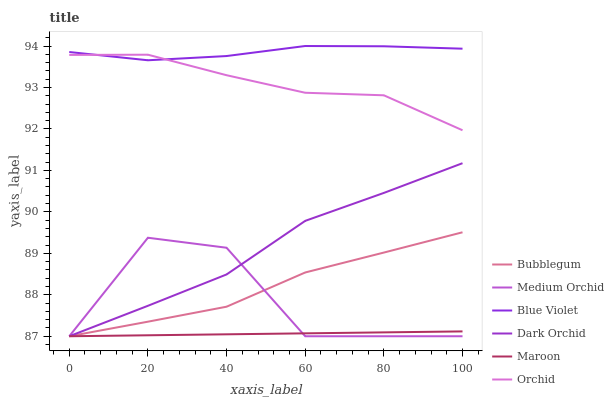Does Maroon have the minimum area under the curve?
Answer yes or no. Yes. Does Blue Violet have the maximum area under the curve?
Answer yes or no. Yes. Does Medium Orchid have the minimum area under the curve?
Answer yes or no. No. Does Medium Orchid have the maximum area under the curve?
Answer yes or no. No. Is Maroon the smoothest?
Answer yes or no. Yes. Is Medium Orchid the roughest?
Answer yes or no. Yes. Is Dark Orchid the smoothest?
Answer yes or no. No. Is Dark Orchid the roughest?
Answer yes or no. No. Does Bubblegum have the lowest value?
Answer yes or no. Yes. Does Blue Violet have the lowest value?
Answer yes or no. No. Does Blue Violet have the highest value?
Answer yes or no. Yes. Does Medium Orchid have the highest value?
Answer yes or no. No. Is Bubblegum less than Orchid?
Answer yes or no. Yes. Is Orchid greater than Bubblegum?
Answer yes or no. Yes. Does Bubblegum intersect Medium Orchid?
Answer yes or no. Yes. Is Bubblegum less than Medium Orchid?
Answer yes or no. No. Is Bubblegum greater than Medium Orchid?
Answer yes or no. No. Does Bubblegum intersect Orchid?
Answer yes or no. No. 